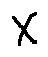<formula> <loc_0><loc_0><loc_500><loc_500>X</formula> 